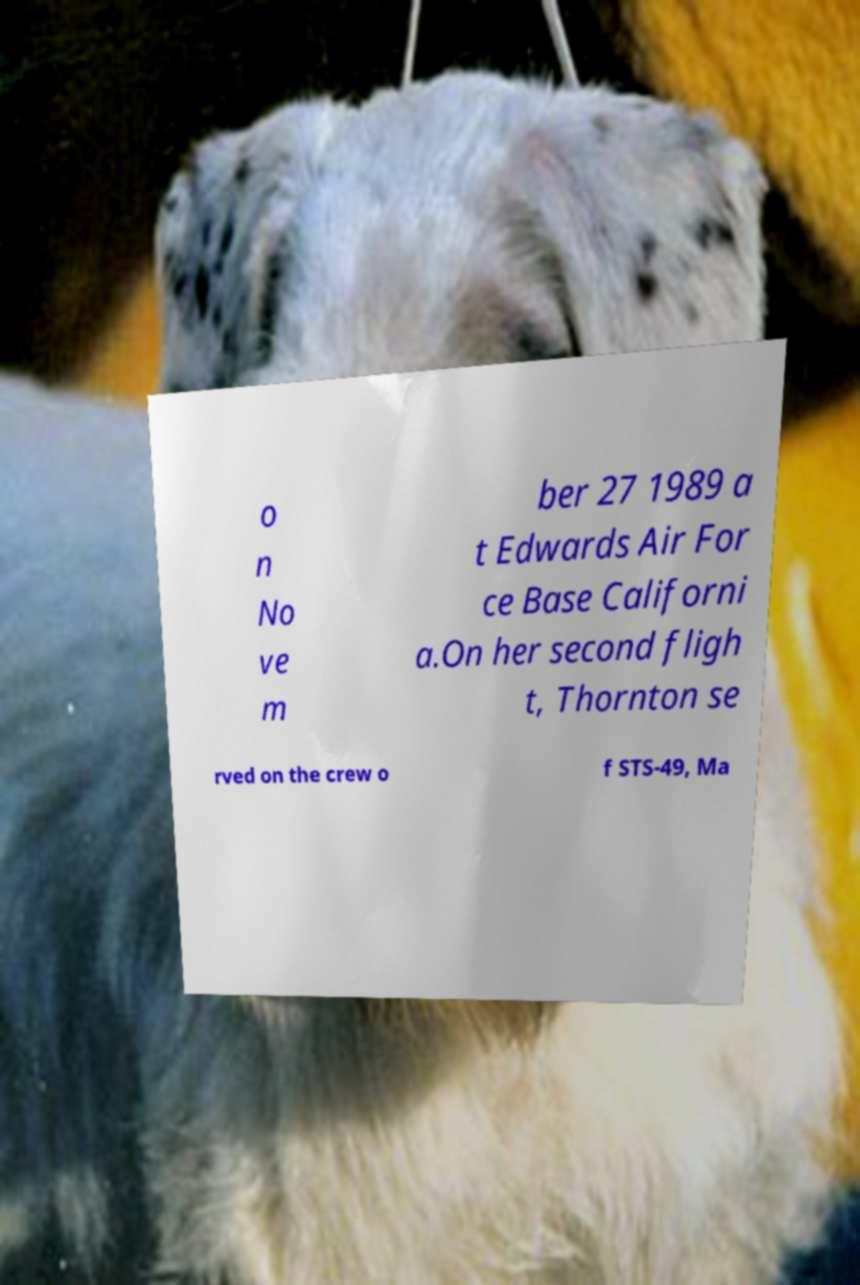Please identify and transcribe the text found in this image. o n No ve m ber 27 1989 a t Edwards Air For ce Base Californi a.On her second fligh t, Thornton se rved on the crew o f STS-49, Ma 